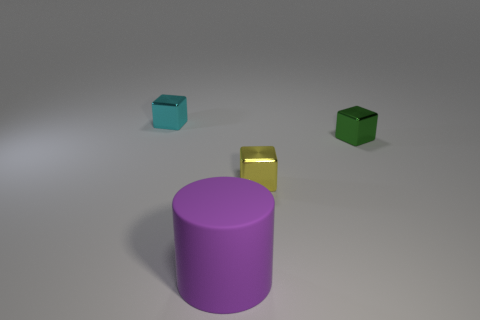Add 1 tiny gray blocks. How many objects exist? 5 Subtract all cubes. How many objects are left? 1 Add 4 yellow objects. How many yellow objects exist? 5 Subtract 0 green cylinders. How many objects are left? 4 Subtract all small shiny blocks. Subtract all small yellow things. How many objects are left? 0 Add 3 shiny objects. How many shiny objects are left? 6 